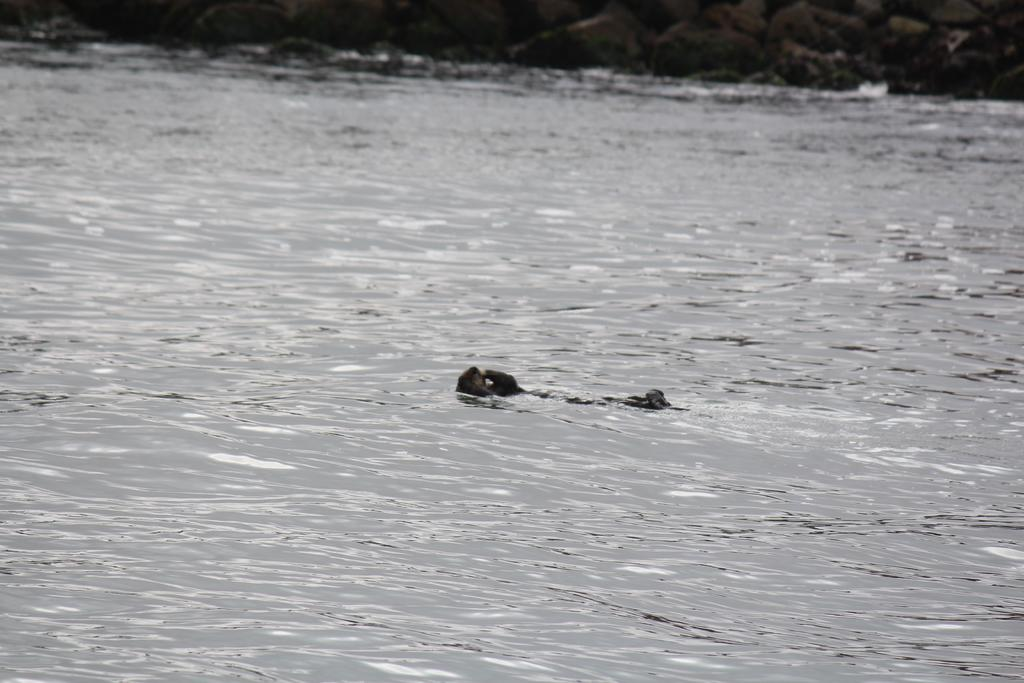What is the color scheme of the image? The image is black and white. What can be seen floating on the water in the image? There is an object floating on the water in the image. What type of vegetation is visible in the background of the image? There are trees visible on the backside in the image. What type of event is taking place in the image? There is no event taking place in the image; it is a still image of an object floating on the water with trees in the background. Can you tell me how the brake system works in the image? There is no vehicle or brake system present in the image; it features an object floating on the water and trees in the background. 